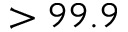Convert formula to latex. <formula><loc_0><loc_0><loc_500><loc_500>> 9 9 . 9</formula> 